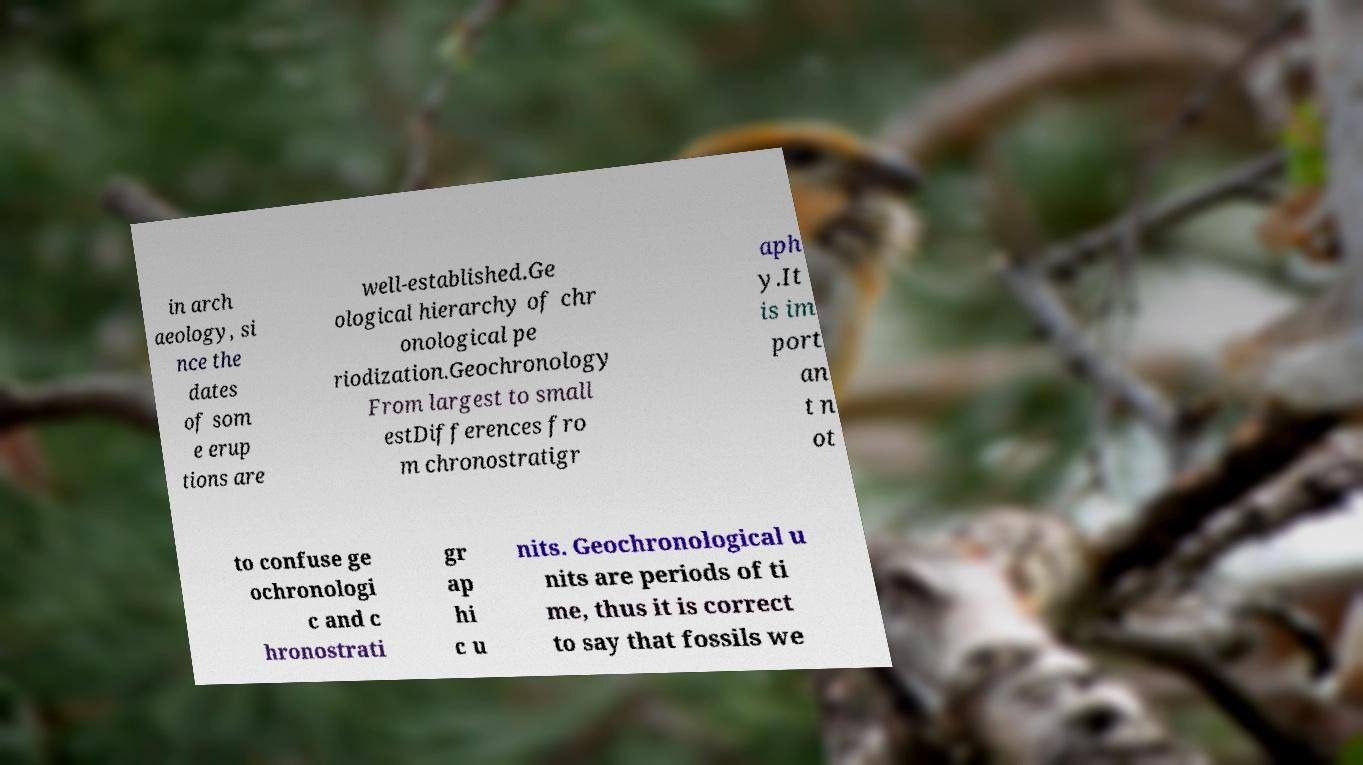Please identify and transcribe the text found in this image. in arch aeology, si nce the dates of som e erup tions are well-established.Ge ological hierarchy of chr onological pe riodization.Geochronology From largest to small estDifferences fro m chronostratigr aph y.It is im port an t n ot to confuse ge ochronologi c and c hronostrati gr ap hi c u nits. Geochronological u nits are periods of ti me, thus it is correct to say that fossils we 